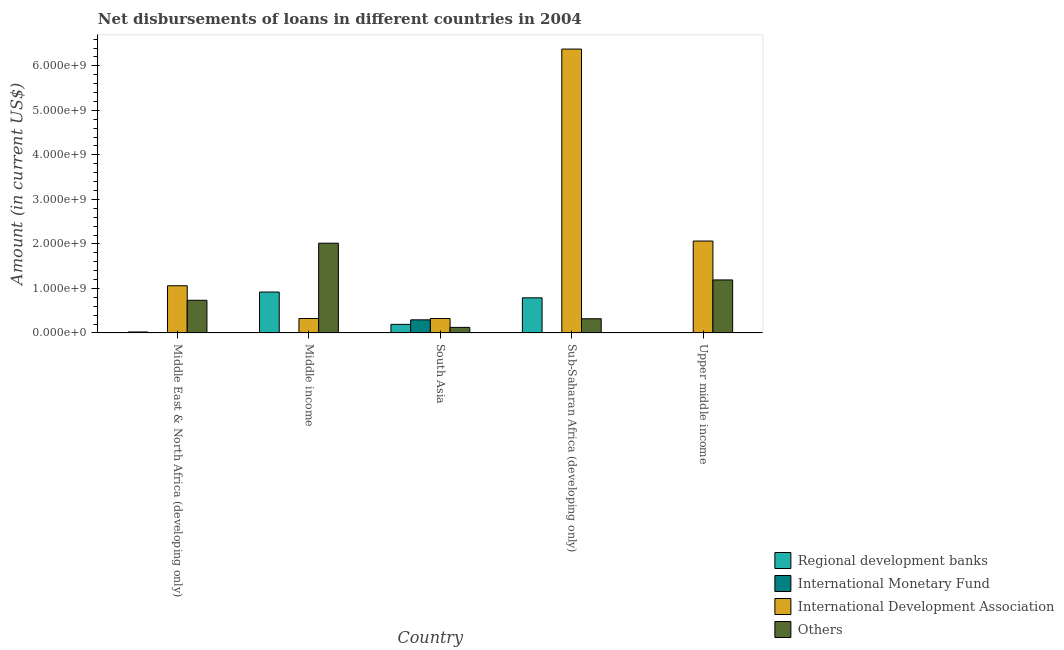How many different coloured bars are there?
Provide a short and direct response. 4. How many groups of bars are there?
Make the answer very short. 5. Are the number of bars per tick equal to the number of legend labels?
Your response must be concise. No. How many bars are there on the 2nd tick from the left?
Ensure brevity in your answer.  3. In how many cases, is the number of bars for a given country not equal to the number of legend labels?
Your answer should be very brief. 4. What is the amount of loan disimbursed by international monetary fund in Upper middle income?
Provide a short and direct response. 0. Across all countries, what is the maximum amount of loan disimbursed by regional development banks?
Your response must be concise. 9.19e+08. Across all countries, what is the minimum amount of loan disimbursed by regional development banks?
Ensure brevity in your answer.  0. In which country was the amount of loan disimbursed by other organisations maximum?
Your response must be concise. Middle income. What is the total amount of loan disimbursed by international development association in the graph?
Keep it short and to the point. 1.01e+1. What is the difference between the amount of loan disimbursed by other organisations in Middle income and that in South Asia?
Offer a very short reply. 1.89e+09. What is the difference between the amount of loan disimbursed by international monetary fund in Upper middle income and the amount of loan disimbursed by international development association in Middle income?
Offer a terse response. -3.24e+08. What is the average amount of loan disimbursed by regional development banks per country?
Your answer should be very brief. 3.84e+08. What is the difference between the amount of loan disimbursed by other organisations and amount of loan disimbursed by international development association in Upper middle income?
Your response must be concise. -8.74e+08. What is the ratio of the amount of loan disimbursed by international development association in South Asia to that in Sub-Saharan Africa (developing only)?
Your answer should be very brief. 0.05. Is the difference between the amount of loan disimbursed by international development association in Middle income and South Asia greater than the difference between the amount of loan disimbursed by regional development banks in Middle income and South Asia?
Provide a short and direct response. No. What is the difference between the highest and the second highest amount of loan disimbursed by other organisations?
Provide a short and direct response. 8.25e+08. What is the difference between the highest and the lowest amount of loan disimbursed by regional development banks?
Offer a terse response. 9.19e+08. Is it the case that in every country, the sum of the amount of loan disimbursed by international monetary fund and amount of loan disimbursed by other organisations is greater than the sum of amount of loan disimbursed by regional development banks and amount of loan disimbursed by international development association?
Provide a short and direct response. No. Is it the case that in every country, the sum of the amount of loan disimbursed by regional development banks and amount of loan disimbursed by international monetary fund is greater than the amount of loan disimbursed by international development association?
Keep it short and to the point. No. How many bars are there?
Ensure brevity in your answer.  15. What is the difference between two consecutive major ticks on the Y-axis?
Your response must be concise. 1.00e+09. Are the values on the major ticks of Y-axis written in scientific E-notation?
Ensure brevity in your answer.  Yes. Does the graph contain any zero values?
Offer a very short reply. Yes. How many legend labels are there?
Make the answer very short. 4. What is the title of the graph?
Give a very brief answer. Net disbursements of loans in different countries in 2004. Does "Tracking ability" appear as one of the legend labels in the graph?
Provide a succinct answer. No. What is the label or title of the X-axis?
Ensure brevity in your answer.  Country. What is the label or title of the Y-axis?
Offer a terse response. Amount (in current US$). What is the Amount (in current US$) of Regional development banks in Middle East & North Africa (developing only)?
Offer a very short reply. 2.18e+07. What is the Amount (in current US$) of International Monetary Fund in Middle East & North Africa (developing only)?
Offer a very short reply. 0. What is the Amount (in current US$) in International Development Association in Middle East & North Africa (developing only)?
Provide a short and direct response. 1.06e+09. What is the Amount (in current US$) of Others in Middle East & North Africa (developing only)?
Provide a short and direct response. 7.34e+08. What is the Amount (in current US$) in Regional development banks in Middle income?
Provide a succinct answer. 9.19e+08. What is the Amount (in current US$) of International Development Association in Middle income?
Ensure brevity in your answer.  3.24e+08. What is the Amount (in current US$) of Others in Middle income?
Keep it short and to the point. 2.02e+09. What is the Amount (in current US$) of Regional development banks in South Asia?
Ensure brevity in your answer.  1.93e+08. What is the Amount (in current US$) in International Monetary Fund in South Asia?
Provide a succinct answer. 2.94e+08. What is the Amount (in current US$) of International Development Association in South Asia?
Your answer should be very brief. 3.24e+08. What is the Amount (in current US$) of Others in South Asia?
Your answer should be very brief. 1.25e+08. What is the Amount (in current US$) of Regional development banks in Sub-Saharan Africa (developing only)?
Offer a very short reply. 7.89e+08. What is the Amount (in current US$) of International Development Association in Sub-Saharan Africa (developing only)?
Give a very brief answer. 6.38e+09. What is the Amount (in current US$) of Others in Sub-Saharan Africa (developing only)?
Provide a short and direct response. 3.19e+08. What is the Amount (in current US$) in International Development Association in Upper middle income?
Keep it short and to the point. 2.06e+09. What is the Amount (in current US$) in Others in Upper middle income?
Keep it short and to the point. 1.19e+09. Across all countries, what is the maximum Amount (in current US$) of Regional development banks?
Provide a succinct answer. 9.19e+08. Across all countries, what is the maximum Amount (in current US$) in International Monetary Fund?
Provide a succinct answer. 2.94e+08. Across all countries, what is the maximum Amount (in current US$) in International Development Association?
Ensure brevity in your answer.  6.38e+09. Across all countries, what is the maximum Amount (in current US$) of Others?
Your response must be concise. 2.02e+09. Across all countries, what is the minimum Amount (in current US$) in Regional development banks?
Keep it short and to the point. 0. Across all countries, what is the minimum Amount (in current US$) in International Monetary Fund?
Your response must be concise. 0. Across all countries, what is the minimum Amount (in current US$) in International Development Association?
Make the answer very short. 3.24e+08. Across all countries, what is the minimum Amount (in current US$) in Others?
Keep it short and to the point. 1.25e+08. What is the total Amount (in current US$) in Regional development banks in the graph?
Ensure brevity in your answer.  1.92e+09. What is the total Amount (in current US$) of International Monetary Fund in the graph?
Ensure brevity in your answer.  2.94e+08. What is the total Amount (in current US$) in International Development Association in the graph?
Keep it short and to the point. 1.01e+1. What is the total Amount (in current US$) of Others in the graph?
Give a very brief answer. 4.38e+09. What is the difference between the Amount (in current US$) of Regional development banks in Middle East & North Africa (developing only) and that in Middle income?
Offer a terse response. -8.97e+08. What is the difference between the Amount (in current US$) of International Development Association in Middle East & North Africa (developing only) and that in Middle income?
Offer a terse response. 7.36e+08. What is the difference between the Amount (in current US$) in Others in Middle East & North Africa (developing only) and that in Middle income?
Offer a very short reply. -1.28e+09. What is the difference between the Amount (in current US$) of Regional development banks in Middle East & North Africa (developing only) and that in South Asia?
Ensure brevity in your answer.  -1.71e+08. What is the difference between the Amount (in current US$) in International Development Association in Middle East & North Africa (developing only) and that in South Asia?
Keep it short and to the point. 7.36e+08. What is the difference between the Amount (in current US$) in Others in Middle East & North Africa (developing only) and that in South Asia?
Offer a terse response. 6.09e+08. What is the difference between the Amount (in current US$) of Regional development banks in Middle East & North Africa (developing only) and that in Sub-Saharan Africa (developing only)?
Provide a succinct answer. -7.67e+08. What is the difference between the Amount (in current US$) of International Development Association in Middle East & North Africa (developing only) and that in Sub-Saharan Africa (developing only)?
Your answer should be compact. -5.32e+09. What is the difference between the Amount (in current US$) in Others in Middle East & North Africa (developing only) and that in Sub-Saharan Africa (developing only)?
Your answer should be very brief. 4.15e+08. What is the difference between the Amount (in current US$) in International Development Association in Middle East & North Africa (developing only) and that in Upper middle income?
Offer a very short reply. -1.00e+09. What is the difference between the Amount (in current US$) of Others in Middle East & North Africa (developing only) and that in Upper middle income?
Keep it short and to the point. -4.57e+08. What is the difference between the Amount (in current US$) in Regional development banks in Middle income and that in South Asia?
Your answer should be compact. 7.26e+08. What is the difference between the Amount (in current US$) of International Development Association in Middle income and that in South Asia?
Your answer should be compact. -4.10e+04. What is the difference between the Amount (in current US$) in Others in Middle income and that in South Asia?
Offer a very short reply. 1.89e+09. What is the difference between the Amount (in current US$) of Regional development banks in Middle income and that in Sub-Saharan Africa (developing only)?
Provide a short and direct response. 1.30e+08. What is the difference between the Amount (in current US$) of International Development Association in Middle income and that in Sub-Saharan Africa (developing only)?
Your response must be concise. -6.05e+09. What is the difference between the Amount (in current US$) in Others in Middle income and that in Sub-Saharan Africa (developing only)?
Keep it short and to the point. 1.70e+09. What is the difference between the Amount (in current US$) of International Development Association in Middle income and that in Upper middle income?
Give a very brief answer. -1.74e+09. What is the difference between the Amount (in current US$) in Others in Middle income and that in Upper middle income?
Your response must be concise. 8.25e+08. What is the difference between the Amount (in current US$) in Regional development banks in South Asia and that in Sub-Saharan Africa (developing only)?
Your response must be concise. -5.96e+08. What is the difference between the Amount (in current US$) of International Development Association in South Asia and that in Sub-Saharan Africa (developing only)?
Your response must be concise. -6.05e+09. What is the difference between the Amount (in current US$) of Others in South Asia and that in Sub-Saharan Africa (developing only)?
Provide a short and direct response. -1.94e+08. What is the difference between the Amount (in current US$) of International Development Association in South Asia and that in Upper middle income?
Offer a terse response. -1.74e+09. What is the difference between the Amount (in current US$) of Others in South Asia and that in Upper middle income?
Ensure brevity in your answer.  -1.07e+09. What is the difference between the Amount (in current US$) of International Development Association in Sub-Saharan Africa (developing only) and that in Upper middle income?
Keep it short and to the point. 4.31e+09. What is the difference between the Amount (in current US$) in Others in Sub-Saharan Africa (developing only) and that in Upper middle income?
Provide a short and direct response. -8.72e+08. What is the difference between the Amount (in current US$) in Regional development banks in Middle East & North Africa (developing only) and the Amount (in current US$) in International Development Association in Middle income?
Provide a short and direct response. -3.02e+08. What is the difference between the Amount (in current US$) in Regional development banks in Middle East & North Africa (developing only) and the Amount (in current US$) in Others in Middle income?
Your answer should be very brief. -1.99e+09. What is the difference between the Amount (in current US$) in International Development Association in Middle East & North Africa (developing only) and the Amount (in current US$) in Others in Middle income?
Your answer should be very brief. -9.56e+08. What is the difference between the Amount (in current US$) of Regional development banks in Middle East & North Africa (developing only) and the Amount (in current US$) of International Monetary Fund in South Asia?
Your answer should be very brief. -2.73e+08. What is the difference between the Amount (in current US$) in Regional development banks in Middle East & North Africa (developing only) and the Amount (in current US$) in International Development Association in South Asia?
Provide a succinct answer. -3.03e+08. What is the difference between the Amount (in current US$) of Regional development banks in Middle East & North Africa (developing only) and the Amount (in current US$) of Others in South Asia?
Offer a terse response. -1.03e+08. What is the difference between the Amount (in current US$) in International Development Association in Middle East & North Africa (developing only) and the Amount (in current US$) in Others in South Asia?
Give a very brief answer. 9.35e+08. What is the difference between the Amount (in current US$) of Regional development banks in Middle East & North Africa (developing only) and the Amount (in current US$) of International Development Association in Sub-Saharan Africa (developing only)?
Your answer should be compact. -6.35e+09. What is the difference between the Amount (in current US$) in Regional development banks in Middle East & North Africa (developing only) and the Amount (in current US$) in Others in Sub-Saharan Africa (developing only)?
Your answer should be very brief. -2.97e+08. What is the difference between the Amount (in current US$) in International Development Association in Middle East & North Africa (developing only) and the Amount (in current US$) in Others in Sub-Saharan Africa (developing only)?
Ensure brevity in your answer.  7.41e+08. What is the difference between the Amount (in current US$) in Regional development banks in Middle East & North Africa (developing only) and the Amount (in current US$) in International Development Association in Upper middle income?
Your answer should be compact. -2.04e+09. What is the difference between the Amount (in current US$) of Regional development banks in Middle East & North Africa (developing only) and the Amount (in current US$) of Others in Upper middle income?
Keep it short and to the point. -1.17e+09. What is the difference between the Amount (in current US$) in International Development Association in Middle East & North Africa (developing only) and the Amount (in current US$) in Others in Upper middle income?
Your answer should be very brief. -1.31e+08. What is the difference between the Amount (in current US$) of Regional development banks in Middle income and the Amount (in current US$) of International Monetary Fund in South Asia?
Your answer should be very brief. 6.24e+08. What is the difference between the Amount (in current US$) of Regional development banks in Middle income and the Amount (in current US$) of International Development Association in South Asia?
Your answer should be compact. 5.94e+08. What is the difference between the Amount (in current US$) of Regional development banks in Middle income and the Amount (in current US$) of Others in South Asia?
Provide a succinct answer. 7.94e+08. What is the difference between the Amount (in current US$) in International Development Association in Middle income and the Amount (in current US$) in Others in South Asia?
Provide a succinct answer. 2.00e+08. What is the difference between the Amount (in current US$) in Regional development banks in Middle income and the Amount (in current US$) in International Development Association in Sub-Saharan Africa (developing only)?
Provide a short and direct response. -5.46e+09. What is the difference between the Amount (in current US$) in Regional development banks in Middle income and the Amount (in current US$) in Others in Sub-Saharan Africa (developing only)?
Ensure brevity in your answer.  6.00e+08. What is the difference between the Amount (in current US$) in International Development Association in Middle income and the Amount (in current US$) in Others in Sub-Saharan Africa (developing only)?
Offer a very short reply. 5.65e+06. What is the difference between the Amount (in current US$) in Regional development banks in Middle income and the Amount (in current US$) in International Development Association in Upper middle income?
Your response must be concise. -1.15e+09. What is the difference between the Amount (in current US$) of Regional development banks in Middle income and the Amount (in current US$) of Others in Upper middle income?
Offer a terse response. -2.72e+08. What is the difference between the Amount (in current US$) in International Development Association in Middle income and the Amount (in current US$) in Others in Upper middle income?
Provide a succinct answer. -8.66e+08. What is the difference between the Amount (in current US$) of Regional development banks in South Asia and the Amount (in current US$) of International Development Association in Sub-Saharan Africa (developing only)?
Your answer should be very brief. -6.18e+09. What is the difference between the Amount (in current US$) of Regional development banks in South Asia and the Amount (in current US$) of Others in Sub-Saharan Africa (developing only)?
Provide a short and direct response. -1.26e+08. What is the difference between the Amount (in current US$) in International Monetary Fund in South Asia and the Amount (in current US$) in International Development Association in Sub-Saharan Africa (developing only)?
Provide a succinct answer. -6.08e+09. What is the difference between the Amount (in current US$) of International Monetary Fund in South Asia and the Amount (in current US$) of Others in Sub-Saharan Africa (developing only)?
Give a very brief answer. -2.43e+07. What is the difference between the Amount (in current US$) of International Development Association in South Asia and the Amount (in current US$) of Others in Sub-Saharan Africa (developing only)?
Your answer should be very brief. 5.69e+06. What is the difference between the Amount (in current US$) in Regional development banks in South Asia and the Amount (in current US$) in International Development Association in Upper middle income?
Your response must be concise. -1.87e+09. What is the difference between the Amount (in current US$) of Regional development banks in South Asia and the Amount (in current US$) of Others in Upper middle income?
Offer a very short reply. -9.98e+08. What is the difference between the Amount (in current US$) of International Monetary Fund in South Asia and the Amount (in current US$) of International Development Association in Upper middle income?
Keep it short and to the point. -1.77e+09. What is the difference between the Amount (in current US$) of International Monetary Fund in South Asia and the Amount (in current US$) of Others in Upper middle income?
Provide a short and direct response. -8.96e+08. What is the difference between the Amount (in current US$) in International Development Association in South Asia and the Amount (in current US$) in Others in Upper middle income?
Provide a succinct answer. -8.66e+08. What is the difference between the Amount (in current US$) in Regional development banks in Sub-Saharan Africa (developing only) and the Amount (in current US$) in International Development Association in Upper middle income?
Your answer should be compact. -1.28e+09. What is the difference between the Amount (in current US$) of Regional development banks in Sub-Saharan Africa (developing only) and the Amount (in current US$) of Others in Upper middle income?
Your answer should be compact. -4.02e+08. What is the difference between the Amount (in current US$) of International Development Association in Sub-Saharan Africa (developing only) and the Amount (in current US$) of Others in Upper middle income?
Your answer should be compact. 5.19e+09. What is the average Amount (in current US$) of Regional development banks per country?
Your answer should be very brief. 3.84e+08. What is the average Amount (in current US$) of International Monetary Fund per country?
Ensure brevity in your answer.  5.89e+07. What is the average Amount (in current US$) of International Development Association per country?
Your response must be concise. 2.03e+09. What is the average Amount (in current US$) of Others per country?
Offer a terse response. 8.77e+08. What is the difference between the Amount (in current US$) of Regional development banks and Amount (in current US$) of International Development Association in Middle East & North Africa (developing only)?
Provide a succinct answer. -1.04e+09. What is the difference between the Amount (in current US$) of Regional development banks and Amount (in current US$) of Others in Middle East & North Africa (developing only)?
Make the answer very short. -7.12e+08. What is the difference between the Amount (in current US$) of International Development Association and Amount (in current US$) of Others in Middle East & North Africa (developing only)?
Provide a short and direct response. 3.26e+08. What is the difference between the Amount (in current US$) in Regional development banks and Amount (in current US$) in International Development Association in Middle income?
Provide a short and direct response. 5.94e+08. What is the difference between the Amount (in current US$) of Regional development banks and Amount (in current US$) of Others in Middle income?
Your answer should be very brief. -1.10e+09. What is the difference between the Amount (in current US$) of International Development Association and Amount (in current US$) of Others in Middle income?
Offer a terse response. -1.69e+09. What is the difference between the Amount (in current US$) in Regional development banks and Amount (in current US$) in International Monetary Fund in South Asia?
Your response must be concise. -1.02e+08. What is the difference between the Amount (in current US$) of Regional development banks and Amount (in current US$) of International Development Association in South Asia?
Offer a terse response. -1.32e+08. What is the difference between the Amount (in current US$) in Regional development banks and Amount (in current US$) in Others in South Asia?
Your answer should be compact. 6.81e+07. What is the difference between the Amount (in current US$) of International Monetary Fund and Amount (in current US$) of International Development Association in South Asia?
Provide a short and direct response. -3.00e+07. What is the difference between the Amount (in current US$) of International Monetary Fund and Amount (in current US$) of Others in South Asia?
Your answer should be very brief. 1.70e+08. What is the difference between the Amount (in current US$) in International Development Association and Amount (in current US$) in Others in South Asia?
Your answer should be very brief. 2.00e+08. What is the difference between the Amount (in current US$) of Regional development banks and Amount (in current US$) of International Development Association in Sub-Saharan Africa (developing only)?
Offer a very short reply. -5.59e+09. What is the difference between the Amount (in current US$) in Regional development banks and Amount (in current US$) in Others in Sub-Saharan Africa (developing only)?
Give a very brief answer. 4.70e+08. What is the difference between the Amount (in current US$) of International Development Association and Amount (in current US$) of Others in Sub-Saharan Africa (developing only)?
Your response must be concise. 6.06e+09. What is the difference between the Amount (in current US$) of International Development Association and Amount (in current US$) of Others in Upper middle income?
Make the answer very short. 8.74e+08. What is the ratio of the Amount (in current US$) in Regional development banks in Middle East & North Africa (developing only) to that in Middle income?
Your answer should be very brief. 0.02. What is the ratio of the Amount (in current US$) in International Development Association in Middle East & North Africa (developing only) to that in Middle income?
Offer a very short reply. 3.27. What is the ratio of the Amount (in current US$) in Others in Middle East & North Africa (developing only) to that in Middle income?
Make the answer very short. 0.36. What is the ratio of the Amount (in current US$) in Regional development banks in Middle East & North Africa (developing only) to that in South Asia?
Offer a terse response. 0.11. What is the ratio of the Amount (in current US$) of International Development Association in Middle East & North Africa (developing only) to that in South Asia?
Give a very brief answer. 3.27. What is the ratio of the Amount (in current US$) in Others in Middle East & North Africa (developing only) to that in South Asia?
Offer a very short reply. 5.88. What is the ratio of the Amount (in current US$) of Regional development banks in Middle East & North Africa (developing only) to that in Sub-Saharan Africa (developing only)?
Provide a short and direct response. 0.03. What is the ratio of the Amount (in current US$) in International Development Association in Middle East & North Africa (developing only) to that in Sub-Saharan Africa (developing only)?
Provide a succinct answer. 0.17. What is the ratio of the Amount (in current US$) of Others in Middle East & North Africa (developing only) to that in Sub-Saharan Africa (developing only)?
Your answer should be compact. 2.3. What is the ratio of the Amount (in current US$) in International Development Association in Middle East & North Africa (developing only) to that in Upper middle income?
Offer a terse response. 0.51. What is the ratio of the Amount (in current US$) in Others in Middle East & North Africa (developing only) to that in Upper middle income?
Provide a short and direct response. 0.62. What is the ratio of the Amount (in current US$) in Regional development banks in Middle income to that in South Asia?
Offer a terse response. 4.77. What is the ratio of the Amount (in current US$) of Others in Middle income to that in South Asia?
Your answer should be very brief. 16.17. What is the ratio of the Amount (in current US$) in Regional development banks in Middle income to that in Sub-Saharan Africa (developing only)?
Ensure brevity in your answer.  1.16. What is the ratio of the Amount (in current US$) of International Development Association in Middle income to that in Sub-Saharan Africa (developing only)?
Offer a terse response. 0.05. What is the ratio of the Amount (in current US$) in Others in Middle income to that in Sub-Saharan Africa (developing only)?
Keep it short and to the point. 6.33. What is the ratio of the Amount (in current US$) in International Development Association in Middle income to that in Upper middle income?
Your answer should be very brief. 0.16. What is the ratio of the Amount (in current US$) of Others in Middle income to that in Upper middle income?
Ensure brevity in your answer.  1.69. What is the ratio of the Amount (in current US$) in Regional development banks in South Asia to that in Sub-Saharan Africa (developing only)?
Keep it short and to the point. 0.24. What is the ratio of the Amount (in current US$) of International Development Association in South Asia to that in Sub-Saharan Africa (developing only)?
Ensure brevity in your answer.  0.05. What is the ratio of the Amount (in current US$) in Others in South Asia to that in Sub-Saharan Africa (developing only)?
Provide a short and direct response. 0.39. What is the ratio of the Amount (in current US$) in International Development Association in South Asia to that in Upper middle income?
Offer a very short reply. 0.16. What is the ratio of the Amount (in current US$) in Others in South Asia to that in Upper middle income?
Provide a succinct answer. 0.1. What is the ratio of the Amount (in current US$) in International Development Association in Sub-Saharan Africa (developing only) to that in Upper middle income?
Provide a short and direct response. 3.09. What is the ratio of the Amount (in current US$) in Others in Sub-Saharan Africa (developing only) to that in Upper middle income?
Provide a succinct answer. 0.27. What is the difference between the highest and the second highest Amount (in current US$) of Regional development banks?
Offer a terse response. 1.30e+08. What is the difference between the highest and the second highest Amount (in current US$) of International Development Association?
Give a very brief answer. 4.31e+09. What is the difference between the highest and the second highest Amount (in current US$) of Others?
Provide a short and direct response. 8.25e+08. What is the difference between the highest and the lowest Amount (in current US$) in Regional development banks?
Offer a very short reply. 9.19e+08. What is the difference between the highest and the lowest Amount (in current US$) of International Monetary Fund?
Provide a short and direct response. 2.94e+08. What is the difference between the highest and the lowest Amount (in current US$) in International Development Association?
Your response must be concise. 6.05e+09. What is the difference between the highest and the lowest Amount (in current US$) in Others?
Provide a short and direct response. 1.89e+09. 